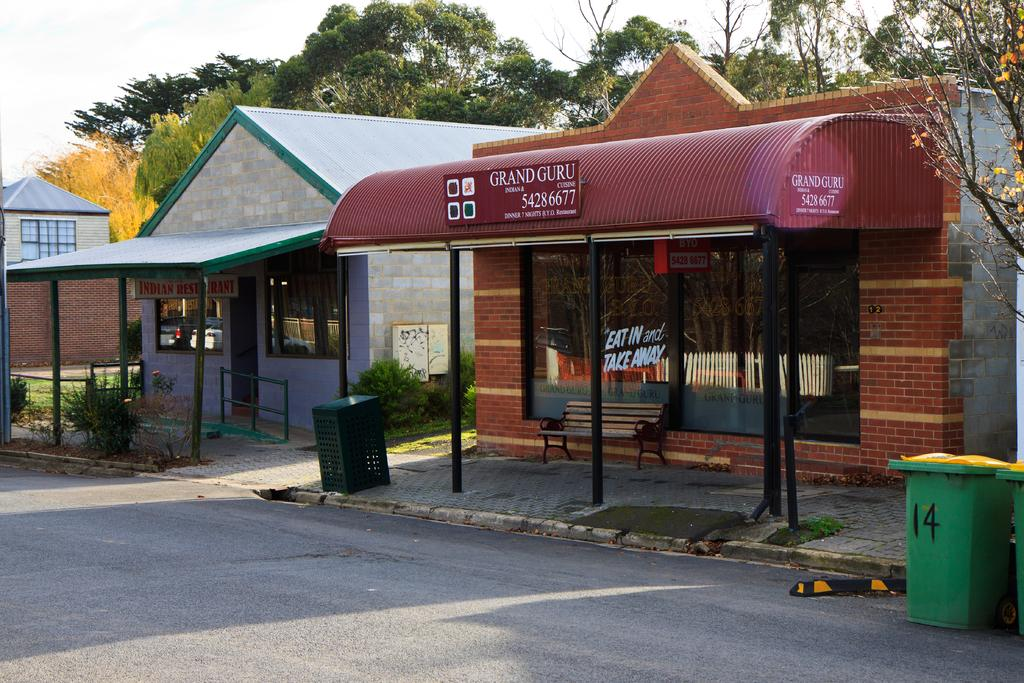What type of structures can be seen in the image? There are buildings in the image. What objects are placed on the walkway? Dustbins are placed on the walkway. What is visible pathway is present in the image? There is a road in the image. What type of vegetation can be seen in the background of the image? There are trees in the backdrop of the image. What is the condition of the sky in the image? The sky is clear in the image. How many cabbages are placed on the shelf in the image? There is no shelf or cabbage present in the image. What time of day is it in the image, based on the hour? The provided facts do not mention the time of day or any hour, so it cannot be determined from the image. 